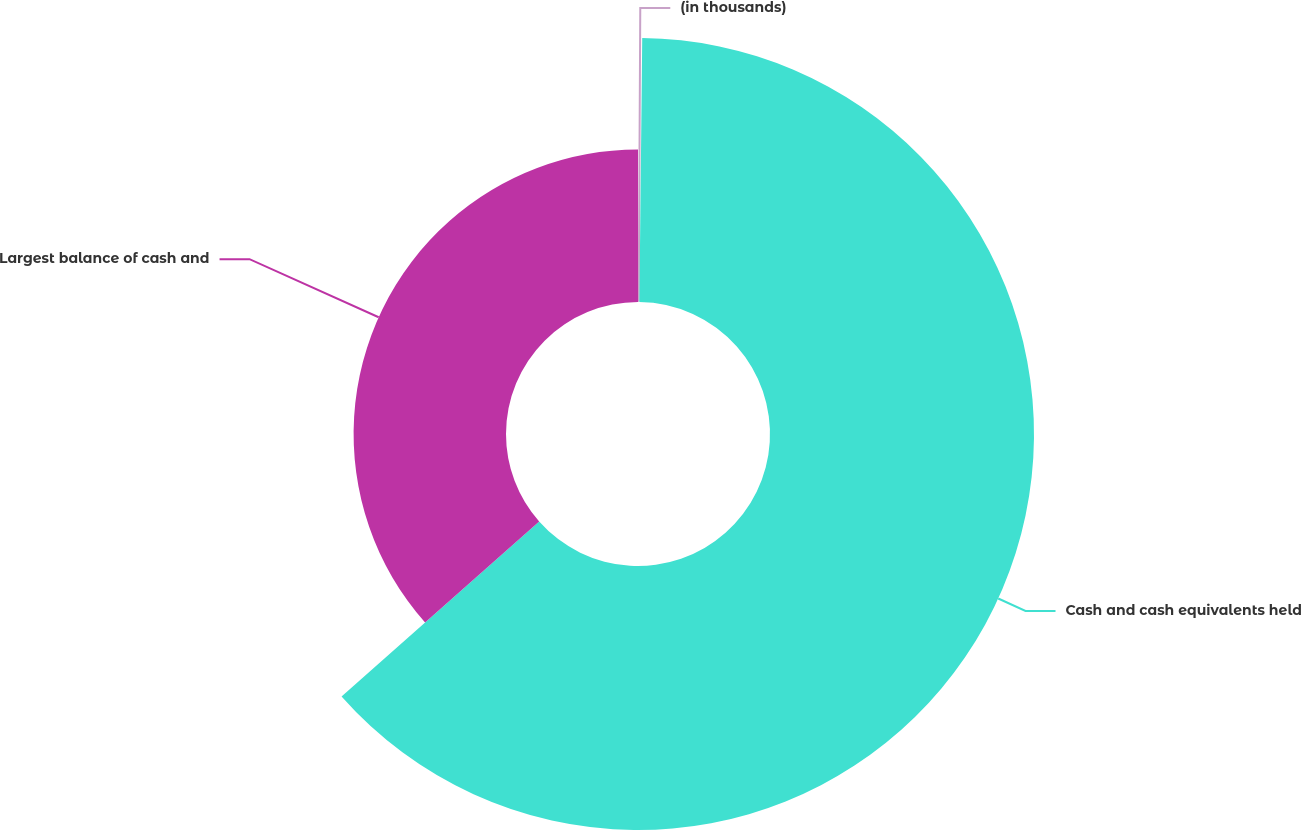Convert chart to OTSL. <chart><loc_0><loc_0><loc_500><loc_500><pie_chart><fcel>(in thousands)<fcel>Cash and cash equivalents held<fcel>Largest balance of cash and<nl><fcel>0.17%<fcel>63.3%<fcel>36.54%<nl></chart> 